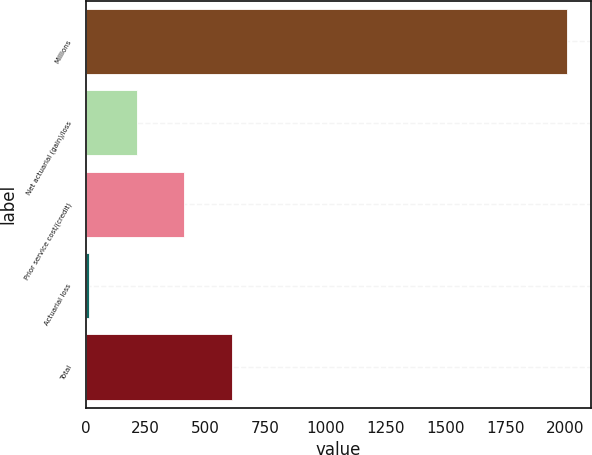Convert chart to OTSL. <chart><loc_0><loc_0><loc_500><loc_500><bar_chart><fcel>Millions<fcel>Net actuarial (gain)/loss<fcel>Prior service cost/(credit)<fcel>Actuarial loss<fcel>Total<nl><fcel>2009<fcel>211.7<fcel>411.4<fcel>12<fcel>611.1<nl></chart> 